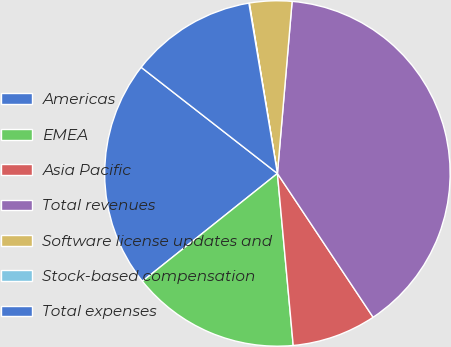<chart> <loc_0><loc_0><loc_500><loc_500><pie_chart><fcel>Americas<fcel>EMEA<fcel>Asia Pacific<fcel>Total revenues<fcel>Software license updates and<fcel>Stock-based compensation<fcel>Total expenses<nl><fcel>21.26%<fcel>15.74%<fcel>7.89%<fcel>39.3%<fcel>3.96%<fcel>0.04%<fcel>11.82%<nl></chart> 